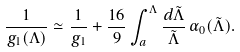Convert formula to latex. <formula><loc_0><loc_0><loc_500><loc_500>\frac { 1 } { g _ { 1 } ( \Lambda ) } \simeq \frac { 1 } { g _ { 1 } } + \frac { 1 6 } { 9 } \int _ { a } ^ { \Lambda } \frac { d \tilde { \Lambda } } { \tilde { \Lambda } } \, \alpha _ { 0 } ( \tilde { \Lambda } ) .</formula> 